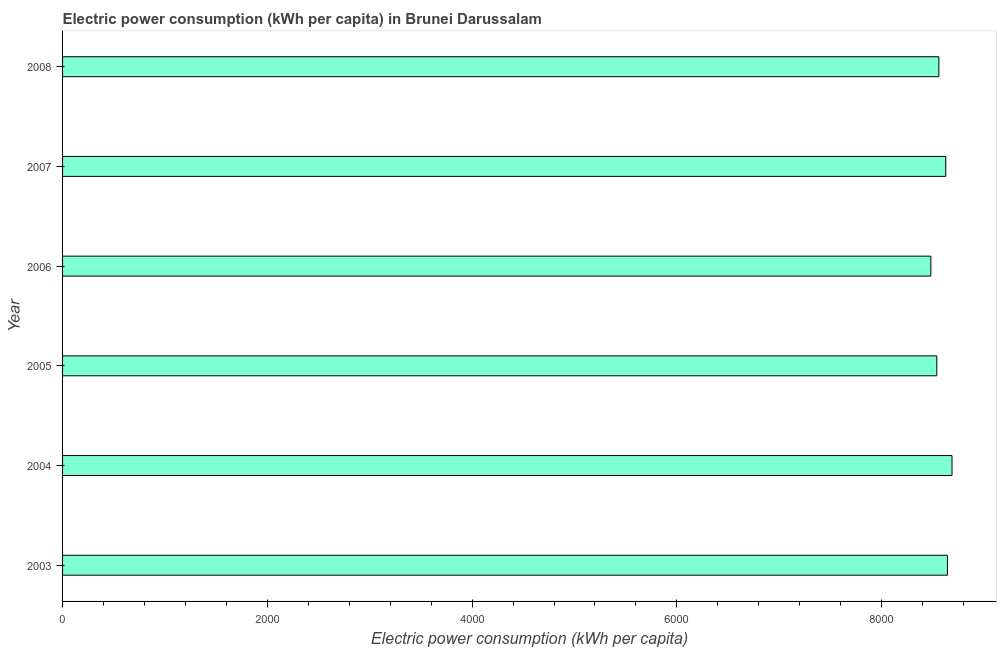Does the graph contain grids?
Provide a short and direct response. No. What is the title of the graph?
Offer a terse response. Electric power consumption (kWh per capita) in Brunei Darussalam. What is the label or title of the X-axis?
Ensure brevity in your answer.  Electric power consumption (kWh per capita). What is the electric power consumption in 2006?
Your response must be concise. 8480.24. Across all years, what is the maximum electric power consumption?
Offer a very short reply. 8687.1. Across all years, what is the minimum electric power consumption?
Ensure brevity in your answer.  8480.24. What is the sum of the electric power consumption?
Your response must be concise. 5.15e+04. What is the difference between the electric power consumption in 2005 and 2006?
Your answer should be compact. 58.29. What is the average electric power consumption per year?
Offer a very short reply. 8588.77. What is the median electric power consumption?
Make the answer very short. 8592.2. In how many years, is the electric power consumption greater than 4800 kWh per capita?
Ensure brevity in your answer.  6. Do a majority of the years between 2008 and 2004 (inclusive) have electric power consumption greater than 8400 kWh per capita?
Keep it short and to the point. Yes. What is the ratio of the electric power consumption in 2004 to that in 2007?
Offer a very short reply. 1.01. Is the electric power consumption in 2005 less than that in 2007?
Your response must be concise. Yes. Is the difference between the electric power consumption in 2003 and 2005 greater than the difference between any two years?
Your response must be concise. No. What is the difference between the highest and the second highest electric power consumption?
Offer a terse response. 44.73. Is the sum of the electric power consumption in 2006 and 2008 greater than the maximum electric power consumption across all years?
Provide a short and direct response. Yes. What is the difference between the highest and the lowest electric power consumption?
Provide a short and direct response. 206.86. How many bars are there?
Provide a succinct answer. 6. What is the Electric power consumption (kWh per capita) in 2003?
Give a very brief answer. 8642.37. What is the Electric power consumption (kWh per capita) of 2004?
Your answer should be very brief. 8687.1. What is the Electric power consumption (kWh per capita) of 2005?
Provide a succinct answer. 8538.53. What is the Electric power consumption (kWh per capita) of 2006?
Your answer should be compact. 8480.24. What is the Electric power consumption (kWh per capita) of 2007?
Your response must be concise. 8625.78. What is the Electric power consumption (kWh per capita) in 2008?
Your answer should be compact. 8558.61. What is the difference between the Electric power consumption (kWh per capita) in 2003 and 2004?
Give a very brief answer. -44.73. What is the difference between the Electric power consumption (kWh per capita) in 2003 and 2005?
Provide a succinct answer. 103.84. What is the difference between the Electric power consumption (kWh per capita) in 2003 and 2006?
Your answer should be very brief. 162.13. What is the difference between the Electric power consumption (kWh per capita) in 2003 and 2007?
Provide a succinct answer. 16.59. What is the difference between the Electric power consumption (kWh per capita) in 2003 and 2008?
Offer a very short reply. 83.75. What is the difference between the Electric power consumption (kWh per capita) in 2004 and 2005?
Your response must be concise. 148.57. What is the difference between the Electric power consumption (kWh per capita) in 2004 and 2006?
Give a very brief answer. 206.86. What is the difference between the Electric power consumption (kWh per capita) in 2004 and 2007?
Offer a terse response. 61.32. What is the difference between the Electric power consumption (kWh per capita) in 2004 and 2008?
Your answer should be compact. 128.48. What is the difference between the Electric power consumption (kWh per capita) in 2005 and 2006?
Provide a short and direct response. 58.29. What is the difference between the Electric power consumption (kWh per capita) in 2005 and 2007?
Your answer should be very brief. -87.25. What is the difference between the Electric power consumption (kWh per capita) in 2005 and 2008?
Provide a succinct answer. -20.08. What is the difference between the Electric power consumption (kWh per capita) in 2006 and 2007?
Your answer should be very brief. -145.54. What is the difference between the Electric power consumption (kWh per capita) in 2006 and 2008?
Offer a very short reply. -78.37. What is the difference between the Electric power consumption (kWh per capita) in 2007 and 2008?
Your answer should be very brief. 67.16. What is the ratio of the Electric power consumption (kWh per capita) in 2003 to that in 2004?
Give a very brief answer. 0.99. What is the ratio of the Electric power consumption (kWh per capita) in 2003 to that in 2006?
Offer a very short reply. 1.02. What is the ratio of the Electric power consumption (kWh per capita) in 2003 to that in 2008?
Provide a succinct answer. 1.01. What is the ratio of the Electric power consumption (kWh per capita) in 2004 to that in 2005?
Ensure brevity in your answer.  1.02. What is the ratio of the Electric power consumption (kWh per capita) in 2004 to that in 2006?
Offer a terse response. 1.02. What is the ratio of the Electric power consumption (kWh per capita) in 2004 to that in 2007?
Give a very brief answer. 1.01. What is the ratio of the Electric power consumption (kWh per capita) in 2004 to that in 2008?
Keep it short and to the point. 1.01. What is the ratio of the Electric power consumption (kWh per capita) in 2005 to that in 2007?
Your response must be concise. 0.99. What is the ratio of the Electric power consumption (kWh per capita) in 2006 to that in 2007?
Your answer should be compact. 0.98. What is the ratio of the Electric power consumption (kWh per capita) in 2006 to that in 2008?
Provide a short and direct response. 0.99. What is the ratio of the Electric power consumption (kWh per capita) in 2007 to that in 2008?
Give a very brief answer. 1.01. 